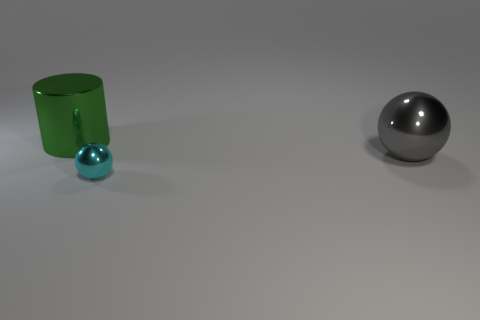Is the number of big green metal cylinders that are in front of the big sphere greater than the number of big balls behind the large green cylinder?
Your answer should be compact. No. The other thing that is the same shape as the cyan metal object is what size?
Provide a short and direct response. Large. How many cylinders are either large green metal objects or tiny cyan metal objects?
Provide a succinct answer. 1. Is the number of objects to the right of the small cyan metallic sphere less than the number of cyan metallic things on the left side of the big green cylinder?
Give a very brief answer. No. How many things are either big spheres right of the tiny cyan metal ball or small cylinders?
Your answer should be very brief. 1. What shape is the big metal object that is behind the big thing that is in front of the big green object?
Make the answer very short. Cylinder. Is there a sphere that has the same size as the green thing?
Make the answer very short. Yes. Are there more big cylinders than metal balls?
Give a very brief answer. No. There is a thing in front of the gray metal sphere; does it have the same size as the shiny thing that is behind the large ball?
Offer a terse response. No. What number of things are on the left side of the gray shiny sphere and in front of the big green metallic object?
Keep it short and to the point. 1. 